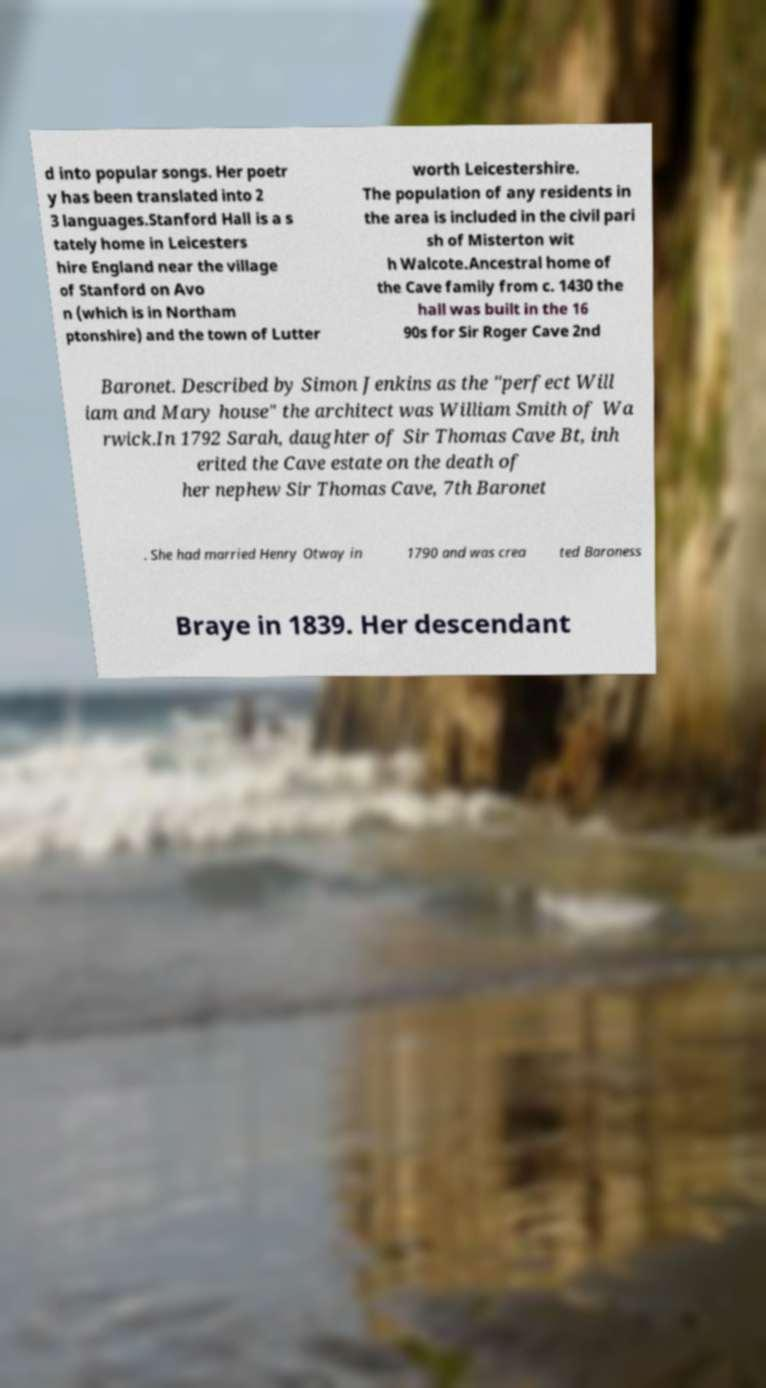For documentation purposes, I need the text within this image transcribed. Could you provide that? d into popular songs. Her poetr y has been translated into 2 3 languages.Stanford Hall is a s tately home in Leicesters hire England near the village of Stanford on Avo n (which is in Northam ptonshire) and the town of Lutter worth Leicestershire. The population of any residents in the area is included in the civil pari sh of Misterton wit h Walcote.Ancestral home of the Cave family from c. 1430 the hall was built in the 16 90s for Sir Roger Cave 2nd Baronet. Described by Simon Jenkins as the "perfect Will iam and Mary house" the architect was William Smith of Wa rwick.In 1792 Sarah, daughter of Sir Thomas Cave Bt, inh erited the Cave estate on the death of her nephew Sir Thomas Cave, 7th Baronet . She had married Henry Otway in 1790 and was crea ted Baroness Braye in 1839. Her descendant 